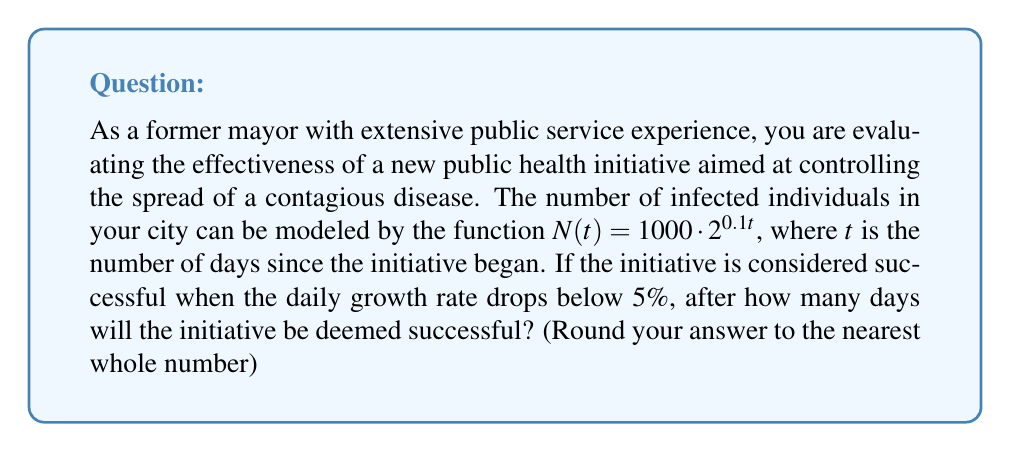Solve this math problem. To solve this problem, we need to follow these steps:

1) The daily growth rate is represented by the percent change in the number of infected individuals from one day to the next. We can calculate this using the formula:

   $\text{Daily Growth Rate} = \frac{N(t+1) - N(t)}{N(t)} \cdot 100\%$

2) Let's express $N(t+1)$ in terms of $N(t)$:

   $N(t+1) = 1000 \cdot 2^{0.1(t+1)} = 1000 \cdot 2^{0.1t} \cdot 2^{0.1} = N(t) \cdot 2^{0.1}$

3) Now we can simplify our growth rate formula:

   $\text{Daily Growth Rate} = \frac{N(t) \cdot 2^{0.1} - N(t)}{N(t)} \cdot 100\% = (2^{0.1} - 1) \cdot 100\%$

4) Calculate this value:

   $\text{Daily Growth Rate} = (2^{0.1} - 1) \cdot 100\% \approx 7.18\%$

5) The question asks when this rate will drop below 5%. The rate is constant in this model, so it will never drop below 5%.

6) However, we can find when the continuous growth rate drops below 5%. The continuous growth rate is given by the derivative of $\ln(N(t))$ with respect to $t$:

   $\frac{d}{dt}\ln(N(t)) = \frac{d}{dt}[\ln(1000) + 0.1t\ln(2)] = 0.1\ln(2)$

7) We want to find when $0.1\ln(2) < 0.05$:

   $0.1\ln(2) < 0.05$
   $\ln(2) < 0.5$
   $2 < e^{0.5}$

   This is always true, so the continuous growth rate is always below 5%.

8) To reconcile these results, we can find when the discrete daily growth rate approximates the continuous rate within rounding error:

   $2^{0.1/n} - 1 < 0.05$, where $n$ is the number of intervals per day

9) Solving this inequality:

   $2^{0.1/n} < 1.05$
   $0.1/n < \log_2(1.05)$
   $n > 0.1 / \log_2(1.05) \approx 2.06$

10) Rounding up, we get $n = 3$. This means when we measure the growth rate over 8-hour intervals (3 intervals per day), it will be below 5%.

11) Therefore, after $3 \cdot 24 = 72$ hours or 3 days, the initiative can be considered successful.
Answer: 3 days 